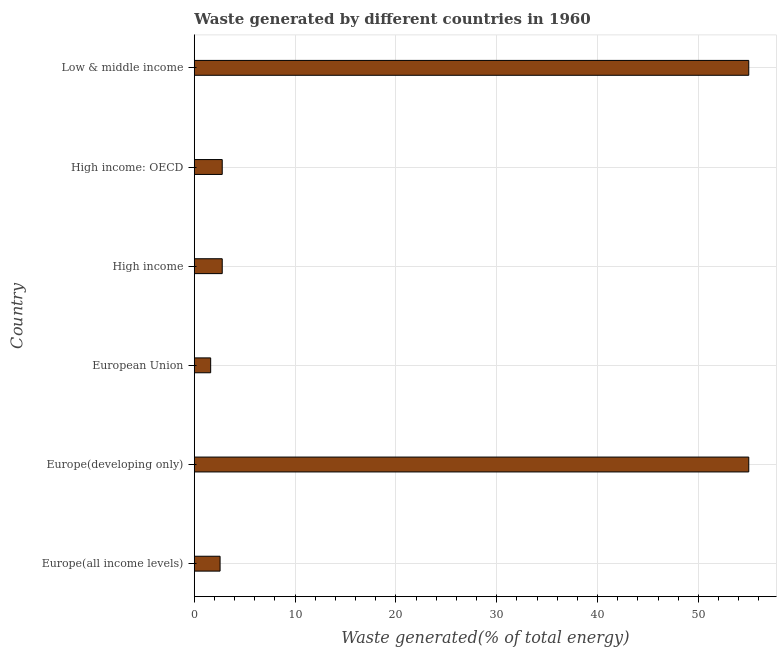What is the title of the graph?
Provide a succinct answer. Waste generated by different countries in 1960. What is the label or title of the X-axis?
Provide a succinct answer. Waste generated(% of total energy). What is the amount of waste generated in High income: OECD?
Your answer should be compact. 2.77. Across all countries, what is the maximum amount of waste generated?
Offer a very short reply. 54.99. Across all countries, what is the minimum amount of waste generated?
Your answer should be very brief. 1.63. In which country was the amount of waste generated maximum?
Your answer should be compact. Europe(developing only). What is the sum of the amount of waste generated?
Keep it short and to the point. 119.72. What is the average amount of waste generated per country?
Make the answer very short. 19.95. What is the median amount of waste generated?
Your answer should be very brief. 2.77. What is the ratio of the amount of waste generated in Europe(all income levels) to that in European Union?
Ensure brevity in your answer.  1.57. Is the difference between the amount of waste generated in Europe(all income levels) and Europe(developing only) greater than the difference between any two countries?
Your response must be concise. No. What is the difference between the highest and the second highest amount of waste generated?
Your answer should be compact. 0. Is the sum of the amount of waste generated in Europe(all income levels) and High income: OECD greater than the maximum amount of waste generated across all countries?
Keep it short and to the point. No. What is the difference between the highest and the lowest amount of waste generated?
Give a very brief answer. 53.37. In how many countries, is the amount of waste generated greater than the average amount of waste generated taken over all countries?
Offer a terse response. 2. Are all the bars in the graph horizontal?
Provide a short and direct response. Yes. What is the Waste generated(% of total energy) in Europe(all income levels)?
Ensure brevity in your answer.  2.56. What is the Waste generated(% of total energy) of Europe(developing only)?
Ensure brevity in your answer.  54.99. What is the Waste generated(% of total energy) of European Union?
Provide a short and direct response. 1.63. What is the Waste generated(% of total energy) in High income?
Make the answer very short. 2.77. What is the Waste generated(% of total energy) of High income: OECD?
Keep it short and to the point. 2.77. What is the Waste generated(% of total energy) in Low & middle income?
Your response must be concise. 54.99. What is the difference between the Waste generated(% of total energy) in Europe(all income levels) and Europe(developing only)?
Offer a very short reply. -52.43. What is the difference between the Waste generated(% of total energy) in Europe(all income levels) and European Union?
Offer a very short reply. 0.93. What is the difference between the Waste generated(% of total energy) in Europe(all income levels) and High income?
Keep it short and to the point. -0.21. What is the difference between the Waste generated(% of total energy) in Europe(all income levels) and High income: OECD?
Offer a very short reply. -0.21. What is the difference between the Waste generated(% of total energy) in Europe(all income levels) and Low & middle income?
Provide a succinct answer. -52.43. What is the difference between the Waste generated(% of total energy) in Europe(developing only) and European Union?
Ensure brevity in your answer.  53.37. What is the difference between the Waste generated(% of total energy) in Europe(developing only) and High income?
Provide a short and direct response. 52.22. What is the difference between the Waste generated(% of total energy) in Europe(developing only) and High income: OECD?
Make the answer very short. 52.22. What is the difference between the Waste generated(% of total energy) in Europe(developing only) and Low & middle income?
Provide a short and direct response. 0. What is the difference between the Waste generated(% of total energy) in European Union and High income?
Offer a terse response. -1.15. What is the difference between the Waste generated(% of total energy) in European Union and High income: OECD?
Give a very brief answer. -1.15. What is the difference between the Waste generated(% of total energy) in European Union and Low & middle income?
Your answer should be very brief. -53.37. What is the difference between the Waste generated(% of total energy) in High income and High income: OECD?
Provide a short and direct response. 0. What is the difference between the Waste generated(% of total energy) in High income and Low & middle income?
Provide a short and direct response. -52.22. What is the difference between the Waste generated(% of total energy) in High income: OECD and Low & middle income?
Provide a succinct answer. -52.22. What is the ratio of the Waste generated(% of total energy) in Europe(all income levels) to that in Europe(developing only)?
Provide a succinct answer. 0.05. What is the ratio of the Waste generated(% of total energy) in Europe(all income levels) to that in European Union?
Provide a succinct answer. 1.57. What is the ratio of the Waste generated(% of total energy) in Europe(all income levels) to that in High income?
Ensure brevity in your answer.  0.92. What is the ratio of the Waste generated(% of total energy) in Europe(all income levels) to that in High income: OECD?
Keep it short and to the point. 0.92. What is the ratio of the Waste generated(% of total energy) in Europe(all income levels) to that in Low & middle income?
Give a very brief answer. 0.05. What is the ratio of the Waste generated(% of total energy) in Europe(developing only) to that in European Union?
Your answer should be compact. 33.8. What is the ratio of the Waste generated(% of total energy) in Europe(developing only) to that in High income?
Offer a very short reply. 19.83. What is the ratio of the Waste generated(% of total energy) in Europe(developing only) to that in High income: OECD?
Ensure brevity in your answer.  19.83. What is the ratio of the Waste generated(% of total energy) in European Union to that in High income?
Your response must be concise. 0.59. What is the ratio of the Waste generated(% of total energy) in European Union to that in High income: OECD?
Your response must be concise. 0.59. What is the ratio of the Waste generated(% of total energy) in High income to that in High income: OECD?
Keep it short and to the point. 1. What is the ratio of the Waste generated(% of total energy) in High income to that in Low & middle income?
Provide a succinct answer. 0.05. 